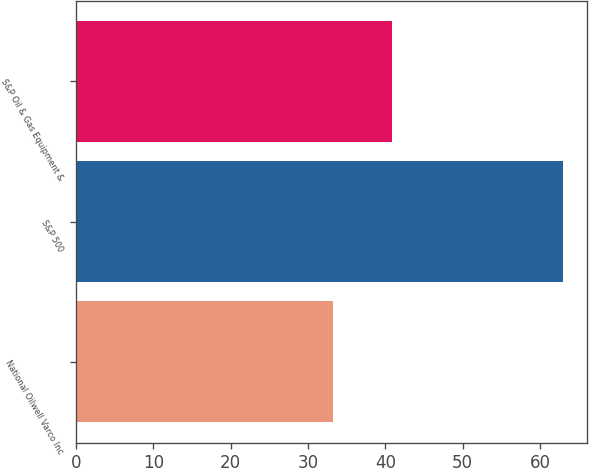Convert chart. <chart><loc_0><loc_0><loc_500><loc_500><bar_chart><fcel>National Oilwell Varco Inc<fcel>S&P 500<fcel>S&P Oil & Gas Equipment &<nl><fcel>33.27<fcel>63<fcel>40.82<nl></chart> 